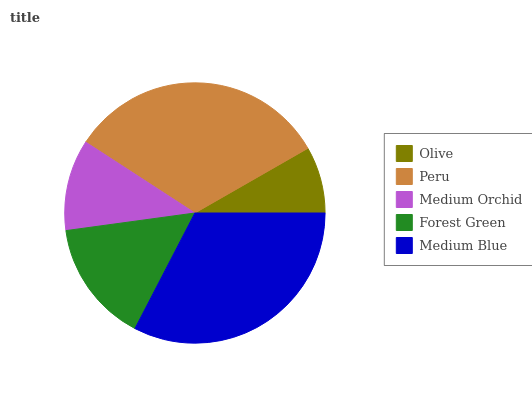Is Olive the minimum?
Answer yes or no. Yes. Is Medium Blue the maximum?
Answer yes or no. Yes. Is Peru the minimum?
Answer yes or no. No. Is Peru the maximum?
Answer yes or no. No. Is Peru greater than Olive?
Answer yes or no. Yes. Is Olive less than Peru?
Answer yes or no. Yes. Is Olive greater than Peru?
Answer yes or no. No. Is Peru less than Olive?
Answer yes or no. No. Is Forest Green the high median?
Answer yes or no. Yes. Is Forest Green the low median?
Answer yes or no. Yes. Is Medium Orchid the high median?
Answer yes or no. No. Is Olive the low median?
Answer yes or no. No. 